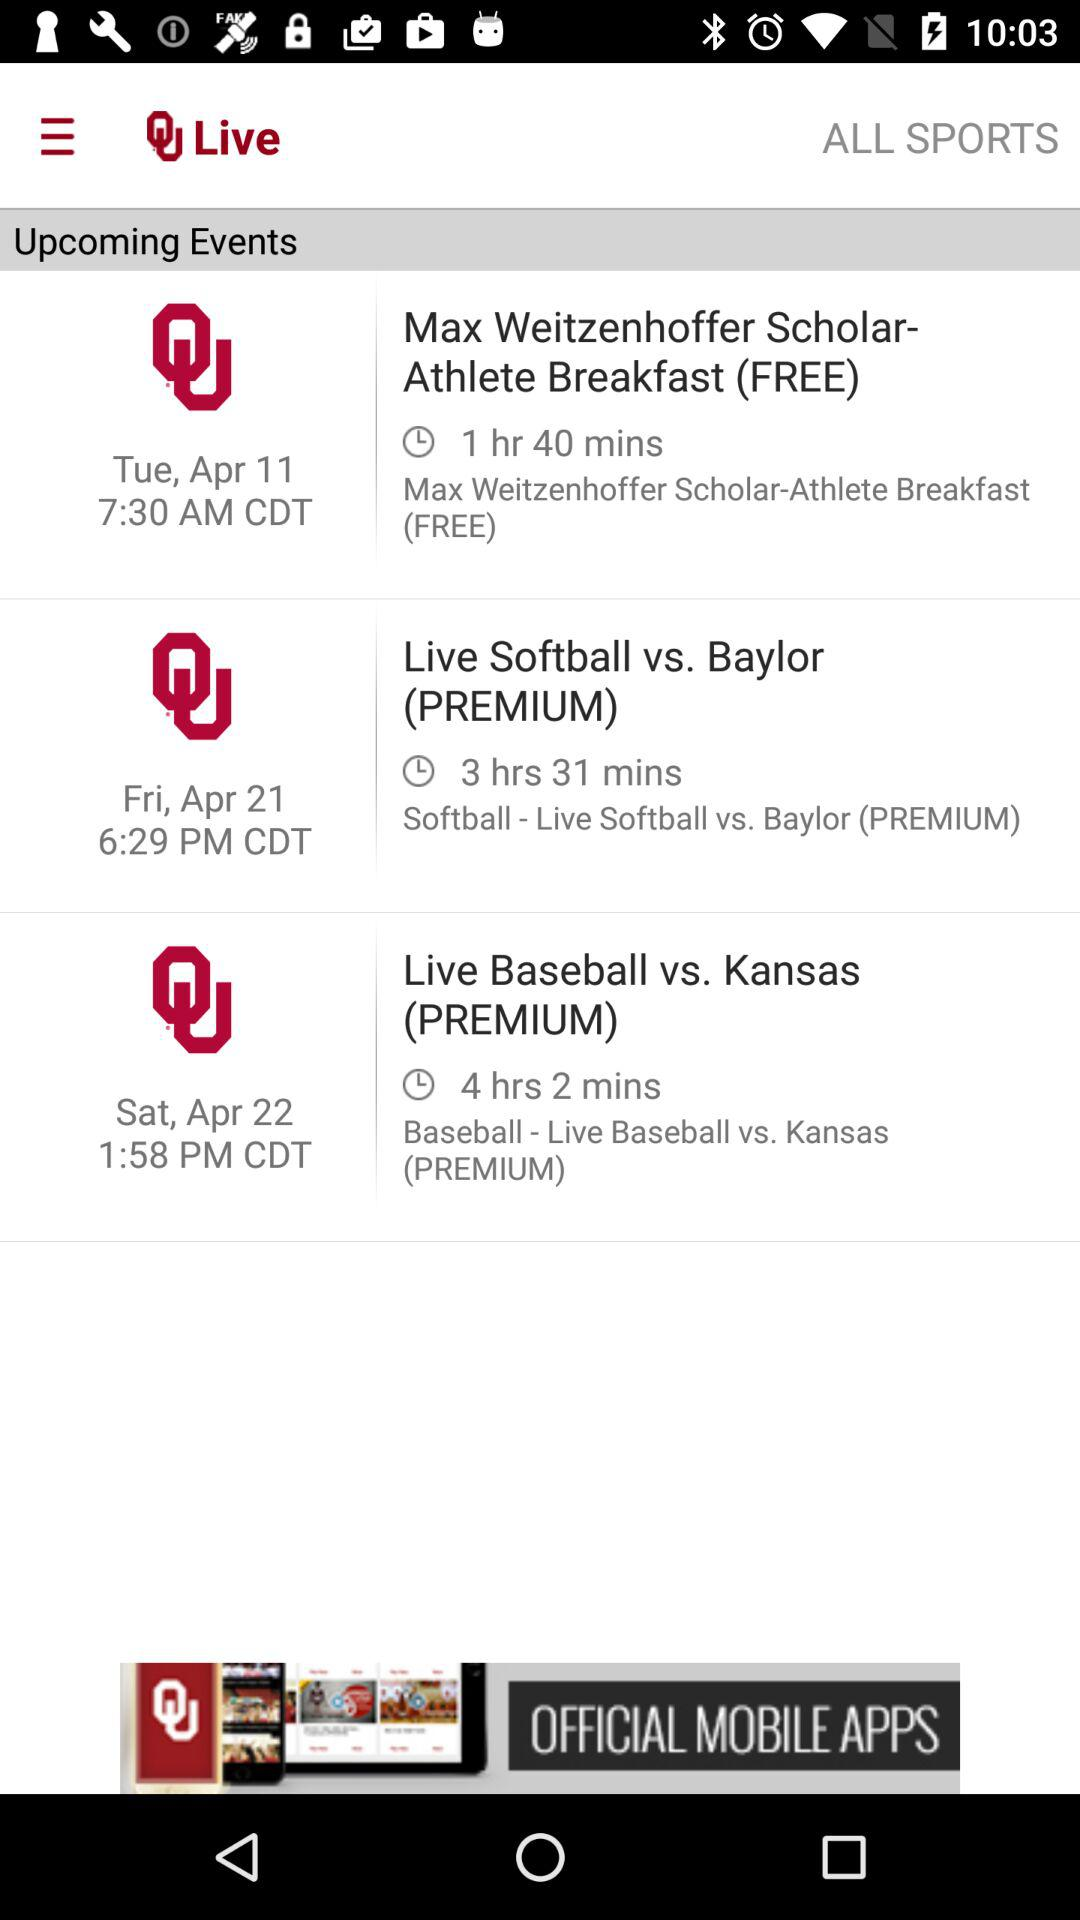What is the date scheduled for the event "Live Softball vs. Baylor (PREMIUM)"? The scheduled date is Friday, April 21. 